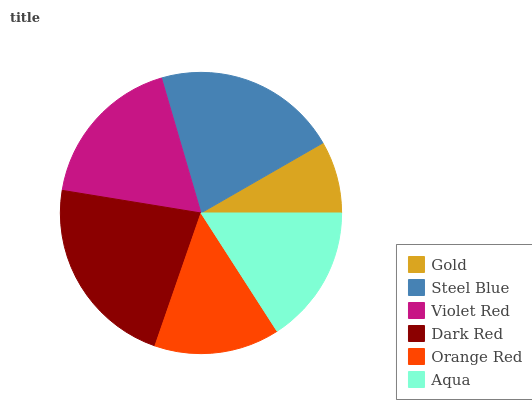Is Gold the minimum?
Answer yes or no. Yes. Is Dark Red the maximum?
Answer yes or no. Yes. Is Steel Blue the minimum?
Answer yes or no. No. Is Steel Blue the maximum?
Answer yes or no. No. Is Steel Blue greater than Gold?
Answer yes or no. Yes. Is Gold less than Steel Blue?
Answer yes or no. Yes. Is Gold greater than Steel Blue?
Answer yes or no. No. Is Steel Blue less than Gold?
Answer yes or no. No. Is Violet Red the high median?
Answer yes or no. Yes. Is Aqua the low median?
Answer yes or no. Yes. Is Steel Blue the high median?
Answer yes or no. No. Is Gold the low median?
Answer yes or no. No. 